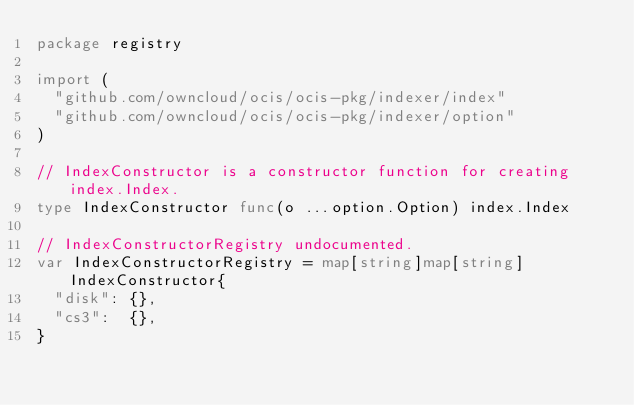<code> <loc_0><loc_0><loc_500><loc_500><_Go_>package registry

import (
	"github.com/owncloud/ocis/ocis-pkg/indexer/index"
	"github.com/owncloud/ocis/ocis-pkg/indexer/option"
)

// IndexConstructor is a constructor function for creating index.Index.
type IndexConstructor func(o ...option.Option) index.Index

// IndexConstructorRegistry undocumented.
var IndexConstructorRegistry = map[string]map[string]IndexConstructor{
	"disk": {},
	"cs3":  {},
}
</code> 